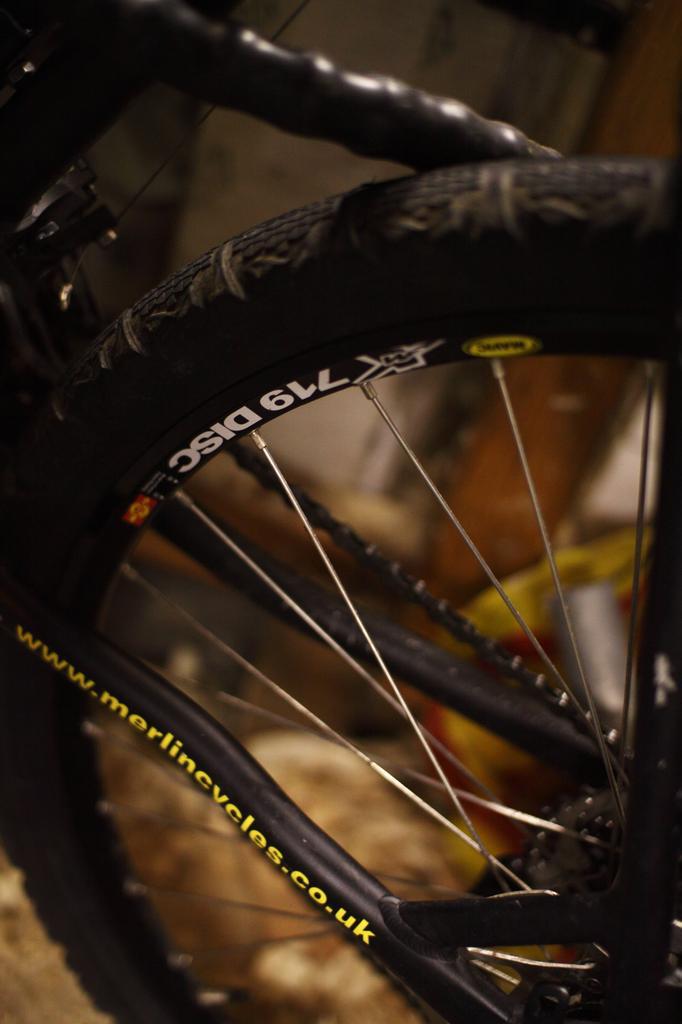Can you describe this image briefly? In this image we can see the bicycle wheel. We can also see the text on the wheel. The background is blurred. 